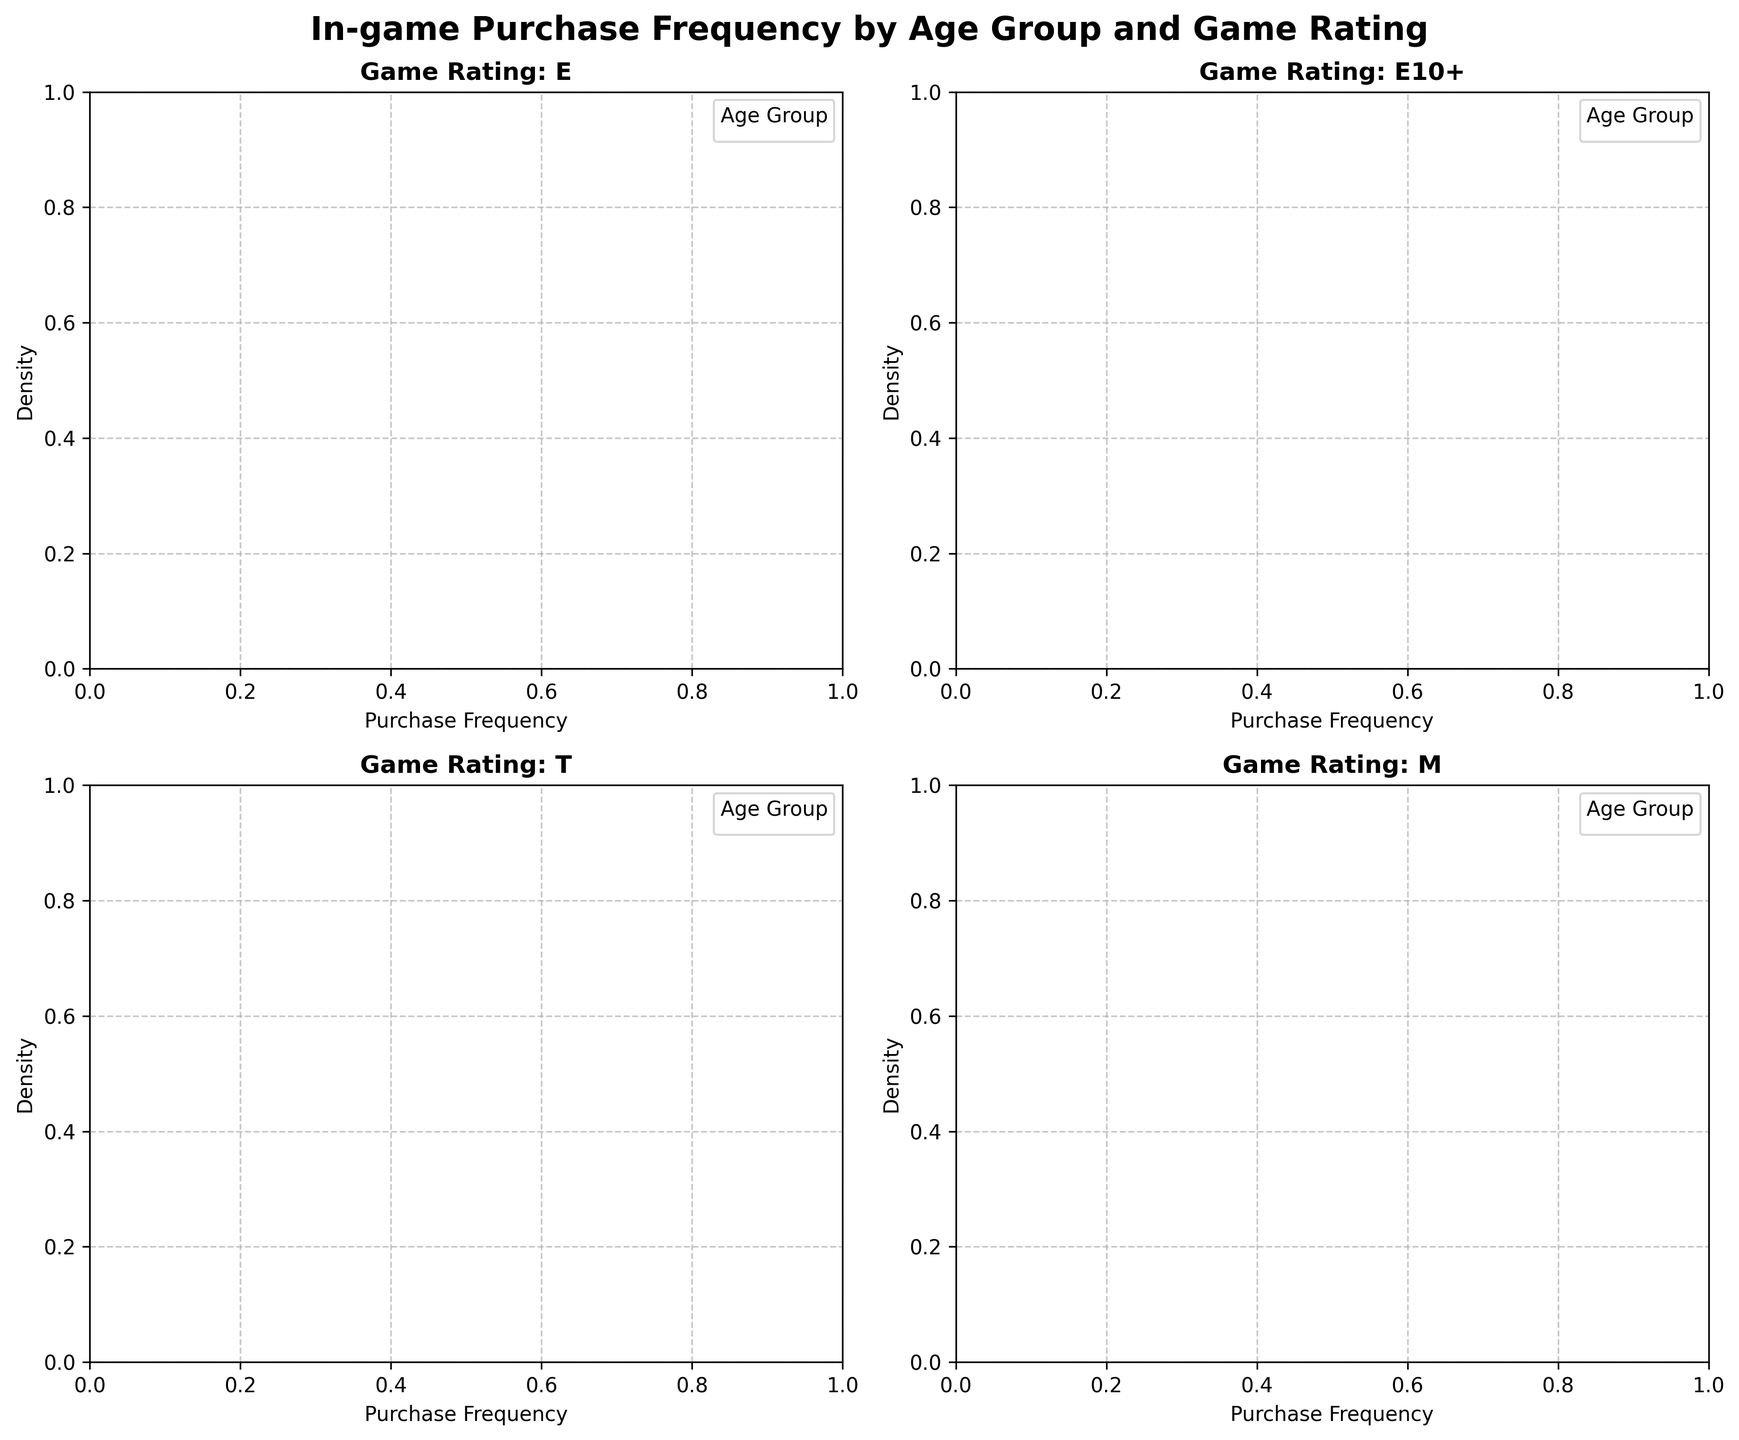What is the title of the figure? The title is prominently displayed at the top center of the figure.
Answer: In-game Purchase Frequency by Age Group and Game Rating What does the x-axis represent in each subplot? The x-axis is labeled "Purchase Frequency," indicating it represents the frequency of in-game purchases.
Answer: Purchase Frequency How many different game ratings are represented in the figure? By counting the number of subplots, each with a different game rating title, we can see that there are 4 game ratings.
Answer: 4 Which age group has the highest density for M-rated games? By examining the subplot for M-rated games, the age group with the highest density curve peak needs to be identified.
Answer: 13-17 Between the age groups 35-44 and 55+, which one shows lower purchase frequency densities for E-rated games? By comparing the E-rated game subplot, the density peaks for both age groups can be observed, and the lower peaks indicate lower frequencies.
Answer: 55+ Which age group shows the steepest decline in density after the peak for T-rated games? In the subplot for T-rated games, observe the steepest post-peak decline in the density curve among the age groups.
Answer: 55+ Do T-rated games show a higher purchase frequency density for age group 13-17 compared to 45-54? Compare the density curves of the age groups 13-17 and 45-54 in the T-rated games subplot.
Answer: Yes Which game rating shows the broadest density distribution for the 25-34 age group? By examining the 25-34 age group's density curves in all subplots, the broadest curve width indicates the broadest density distribution.
Answer: M Is the purchase frequency density higher for 18-24 age group in E-rated or E10+-rated games? Compare the density curves of the 18-24 age group in the subplots for E-rated and E10+-rated games.
Answer: E10+ Which age group has the lowest purchase frequency density peak in E10+-rated games, and what might this imply? Identify the age group with the lowest peak in the E10+-rated games subplot and consider its implications, such as lesser engagement with these game types.
Answer: 55+, Less engagement with E10+ games 